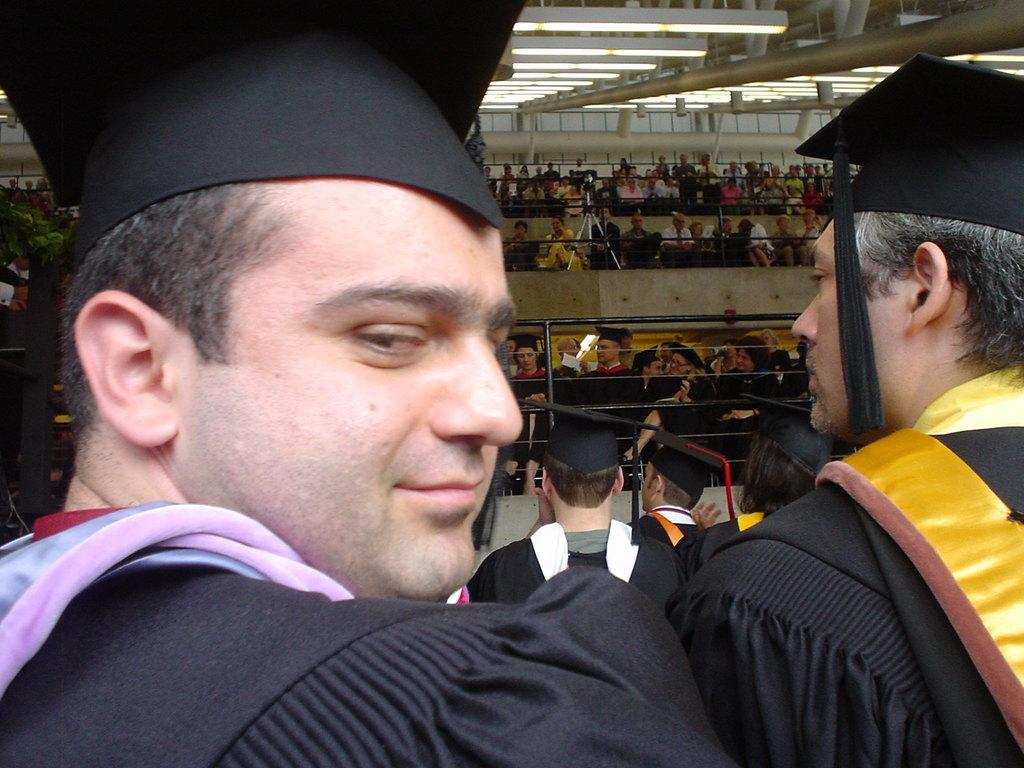What are the two people in the image wearing? The two people in the image are wearing convocation dress. Can you describe the other people present in the image? There are other people present in the image, but their clothing is not specified. What is on the roof in the image? There are lights on the roof in the image. What statement does the governor make in the image? There is no governor present in the image, and therefore no statement can be attributed to them. 